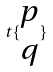<formula> <loc_0><loc_0><loc_500><loc_500>t \{ \begin{matrix} p \\ q \end{matrix} \}</formula> 